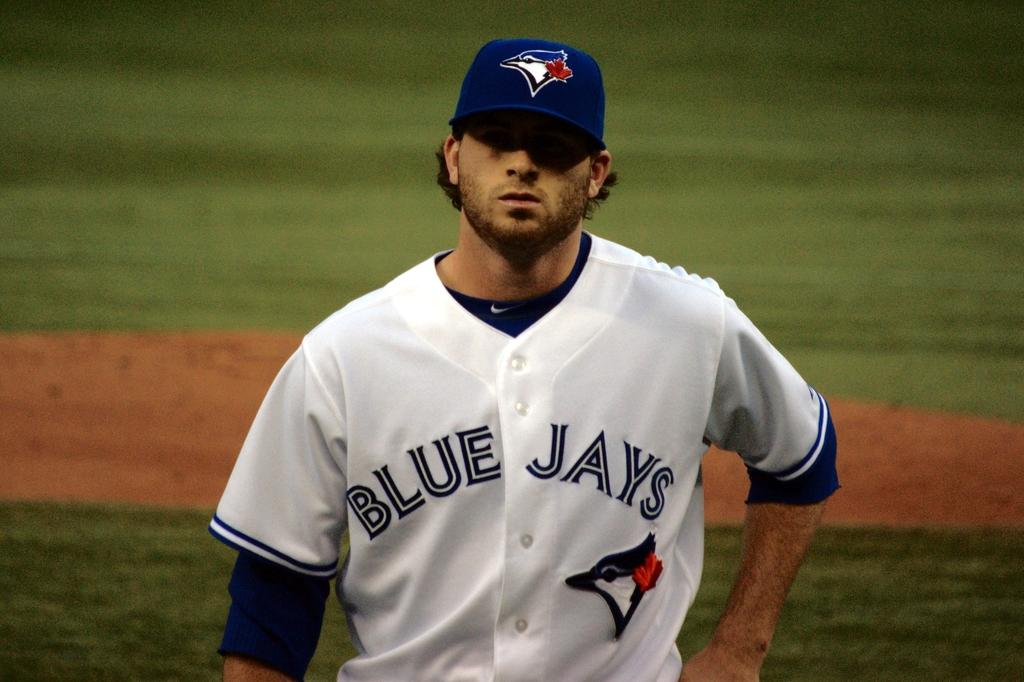What color is the team name on the jersey?
Make the answer very short. Blue. 